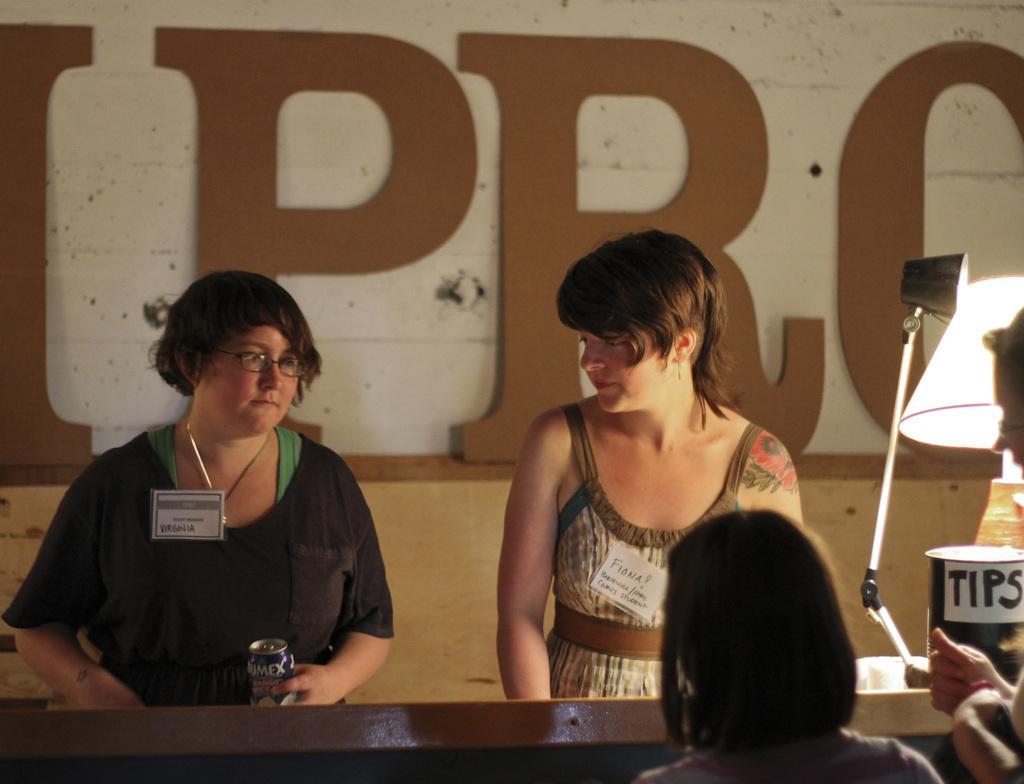Could you give a brief overview of what you see in this image? Here we have 2 ladies who are wearing id cards and the leftmost lady is holding some bottle and this lady is looking at her. In front of them there is a desk and at top right, we have lamp, tips box. This seems like reception and here we have 2 ladies who are asking or inquiring. 